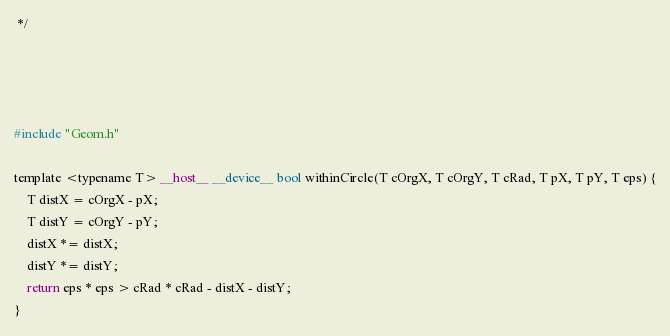<code> <loc_0><loc_0><loc_500><loc_500><_Cuda_> */




#include "Geom.h"

template <typename T> __host__ __device__ bool withinCircle(T cOrgX, T cOrgY, T cRad, T pX, T pY, T eps) {
	T distX = cOrgX - pX;
	T distY = cOrgY - pY;
	distX *= distX;
	distY *= distY;
	return eps * eps > cRad * cRad - distX - distY;
}
</code> 